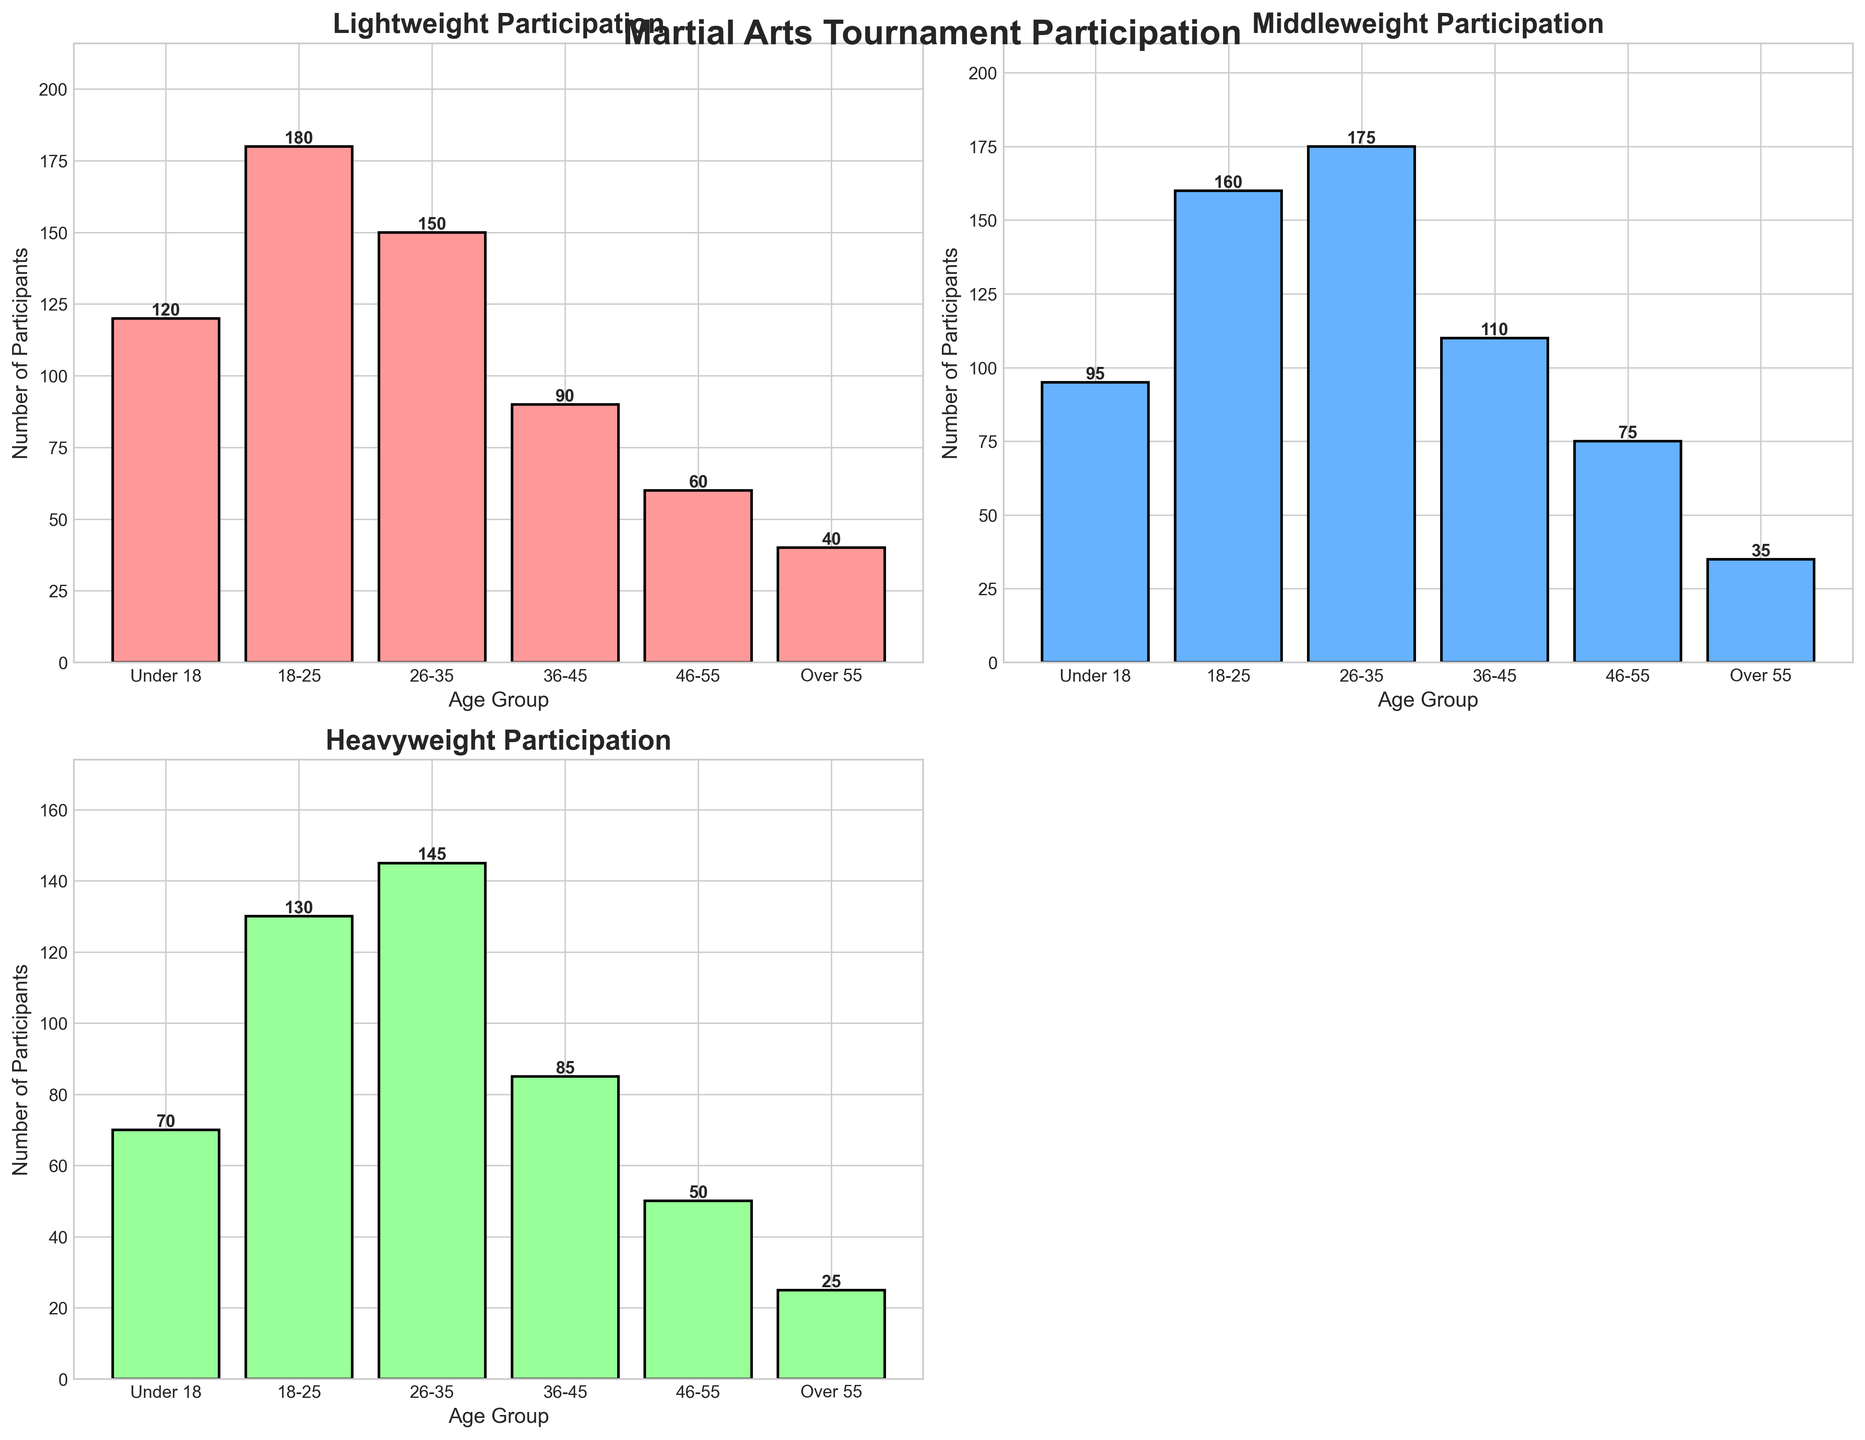How many more participants are there in the 18-25 age group compared to the 46-55 age group in the Lightweight category? The 18-25 age group has 180 participants in the Lightweight category. The 46-55 age group has 60 participants. The difference is 180 - 60 = 120.
Answer: 120 Which age group has the highest participation in the Heavyweight category? By looking at the bar heights in the Heavyweight subplots, the 18-25 age group has the highest participation with 130 participants.
Answer: 18-25 What is the total number of participants in the Middleweight category for all age groups? Sum the number of participants in the Middleweight category across all age groups: 95 + 160 + 175 + 110 + 75 + 35 = 650.
Answer: 650 In the 26-35 age group, how does the number of participants in the Middleweight category compare to the Lightweight category? The 26-35 age group has 175 participants in the Middleweight category and 150 in the Lightweight category. 175 is more significant than 150.
Answer: Middleweight > Lightweight Which weight class has the smallest total number of participants across all age groups? Sum each weight class: Lightweight (120 + 180 + 150 + 90 + 60 + 40 = 640), Middleweight (95 + 160 + 175 + 110 + 75 + 35 = 650), Heavyweight (70 + 130 + 145 + 85 + 50 + 25 = 505). Heavyweight has the smallest total.
Answer: Heavyweight How many more participants are in the 36-45 age group compared to the Over 55 age group in the Middleweight category? The 36-45 age group has 110 participants, and the Over 55 age group has 35 in the Middleweight category. The difference is 110 - 35 = 75.
Answer: 75 Which age group has the smallest number of participants in the Lightweight category? By comparing the heights of the bars in the Lightweight subplot, the Over 55 age group has the smallest number of participants with 40.
Answer: Over 55 What's the average number of participants in the Heavyweight category across all age groups? There are six age groups with participant counts of 70, 130, 145, 85, 50, and 25 in the Heavyweight category. The total is 70 + 130 + 145 + 85 + 50 + 25 = 505. The average is 505 / 6 ≈ 84.17.
Answer: 84.17 In the 18-25 age group, which weight class has the least number of participants? For the 18-25 age group, the number of participants is 180 (Lightweight), 160 (Middleweight), and 130 (Heavyweight). Heavyweight has the least number of participants.
Answer: Heavyweight What is the total participation in all weight classes for the 46-55 age group? Sum the participants in the 46-55 age group across all weight classes: 60 (Lightweight) + 75 (Middleweight) + 50 (Heavyweight) = 185.
Answer: 185 